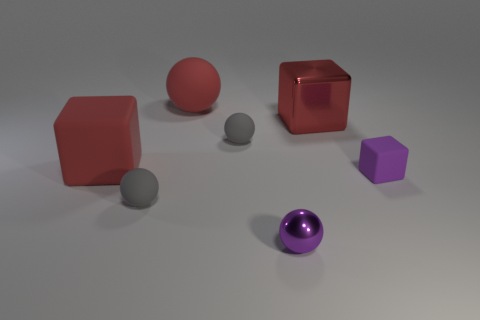How many small gray matte objects are on the right side of the matte cube right of the red rubber cube?
Your response must be concise. 0. There is a metallic ball; is it the same color as the metal object that is behind the small metal object?
Offer a very short reply. No. What number of other metallic things have the same shape as the small metallic object?
Your answer should be very brief. 0. What material is the small object that is right of the red metallic object?
Provide a short and direct response. Rubber. Do the red thing that is on the left side of the red ball and the small purple shiny thing have the same shape?
Your answer should be compact. No. Are there any metallic objects that have the same size as the metal sphere?
Provide a short and direct response. No. Is the shape of the small shiny object the same as the metallic thing behind the small purple matte thing?
Keep it short and to the point. No. The big matte thing that is the same color as the big matte sphere is what shape?
Your response must be concise. Cube. Are there fewer small shiny balls in front of the metallic sphere than purple matte spheres?
Offer a very short reply. No. Do the large red metallic thing and the tiny purple matte thing have the same shape?
Make the answer very short. Yes. 